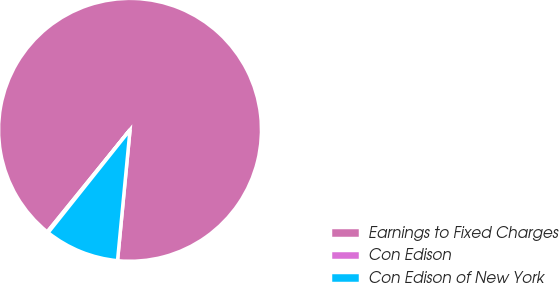<chart> <loc_0><loc_0><loc_500><loc_500><pie_chart><fcel>Earnings to Fixed Charges<fcel>Con Edison<fcel>Con Edison of New York<nl><fcel>90.67%<fcel>0.14%<fcel>9.19%<nl></chart> 